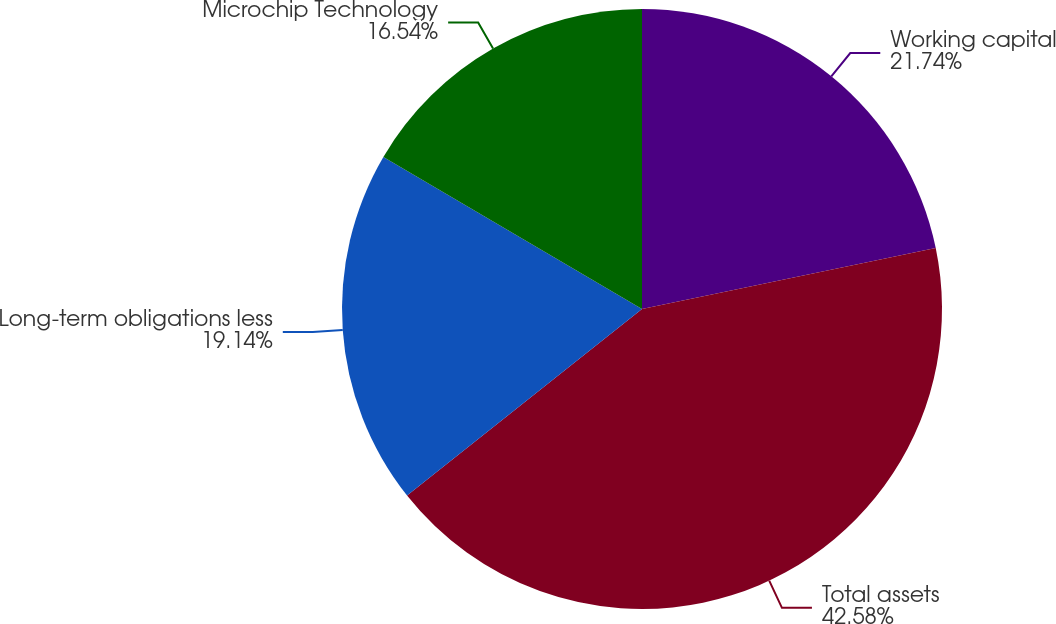<chart> <loc_0><loc_0><loc_500><loc_500><pie_chart><fcel>Working capital<fcel>Total assets<fcel>Long-term obligations less<fcel>Microchip Technology<nl><fcel>21.74%<fcel>42.58%<fcel>19.14%<fcel>16.54%<nl></chart> 